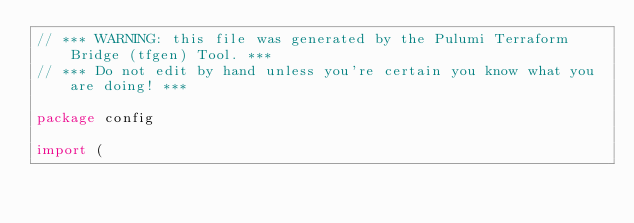Convert code to text. <code><loc_0><loc_0><loc_500><loc_500><_Go_>// *** WARNING: this file was generated by the Pulumi Terraform Bridge (tfgen) Tool. ***
// *** Do not edit by hand unless you're certain you know what you are doing! ***

package config

import (</code> 